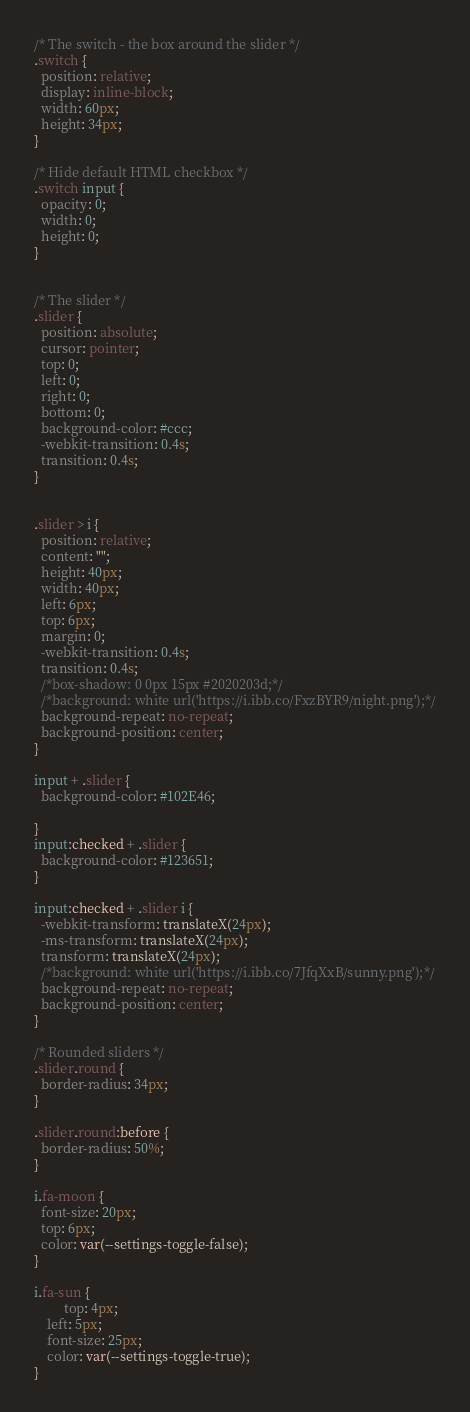<code> <loc_0><loc_0><loc_500><loc_500><_CSS_>/* The switch - the box around the slider */
.switch {
  position: relative;
  display: inline-block;
  width: 60px;
  height: 34px;
}

/* Hide default HTML checkbox */
.switch input {
  opacity: 0;
  width: 0;
  height: 0;
}


/* The slider */
.slider {
  position: absolute;
  cursor: pointer;
  top: 0;
  left: 0;
  right: 0;
  bottom: 0;
  background-color: #ccc;
  -webkit-transition: 0.4s;
  transition: 0.4s;
}


.slider > i {
  position: relative;
  content: "";
  height: 40px;
  width: 40px;
  left: 6px;
  top: 6px;
  margin: 0;
  -webkit-transition: 0.4s;
  transition: 0.4s;
  /*box-shadow: 0 0px 15px #2020203d;*/
  /*background: white url('https://i.ibb.co/FxzBYR9/night.png');*/
  background-repeat: no-repeat;
  background-position: center;
}

input + .slider {
  background-color: #102E46;

}
input:checked + .slider {
  background-color: #123651;
}

input:checked + .slider i {
  -webkit-transform: translateX(24px);
  -ms-transform: translateX(24px);
  transform: translateX(24px);
  /*background: white url('https://i.ibb.co/7JfqXxB/sunny.png');*/
  background-repeat: no-repeat;
  background-position: center;
}

/* Rounded sliders */
.slider.round {
  border-radius: 34px;
}

.slider.round:before {
  border-radius: 50%;
}

i.fa-moon {
  font-size: 20px;
  top: 6px;
  color: var(--settings-toggle-false);
}

i.fa-sun {
         top: 4px;
    left: 5px;
    font-size: 25px;
    color: var(--settings-toggle-true);
}</code> 